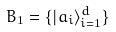<formula> <loc_0><loc_0><loc_500><loc_500>B _ { 1 } = \{ | a _ { i } \rangle _ { i = 1 } ^ { d } \}</formula> 